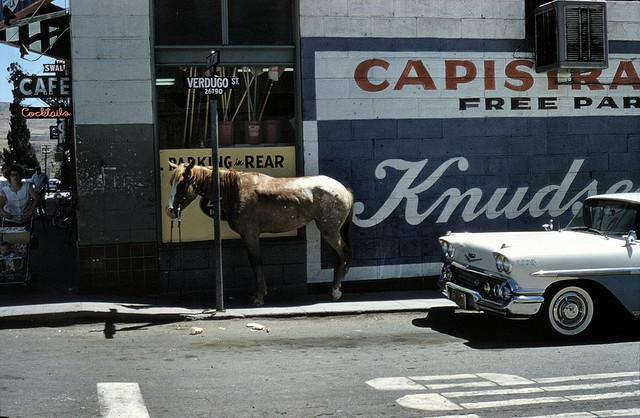This animal is frequently used as transportation by what profession? cowboy 